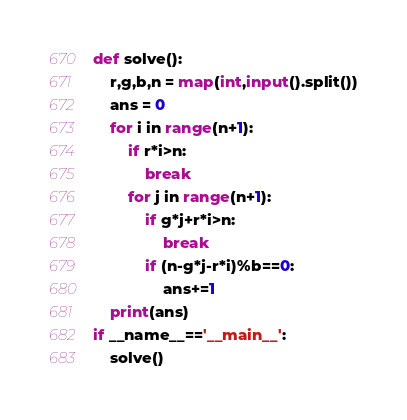Convert code to text. <code><loc_0><loc_0><loc_500><loc_500><_Python_>def solve():
    r,g,b,n = map(int,input().split())
    ans = 0
    for i in range(n+1):
        if r*i>n:
            break
        for j in range(n+1):
            if g*j+r*i>n:
                break
            if (n-g*j-r*i)%b==0:
                ans+=1
    print(ans)
if __name__=='__main__':
    solve()</code> 